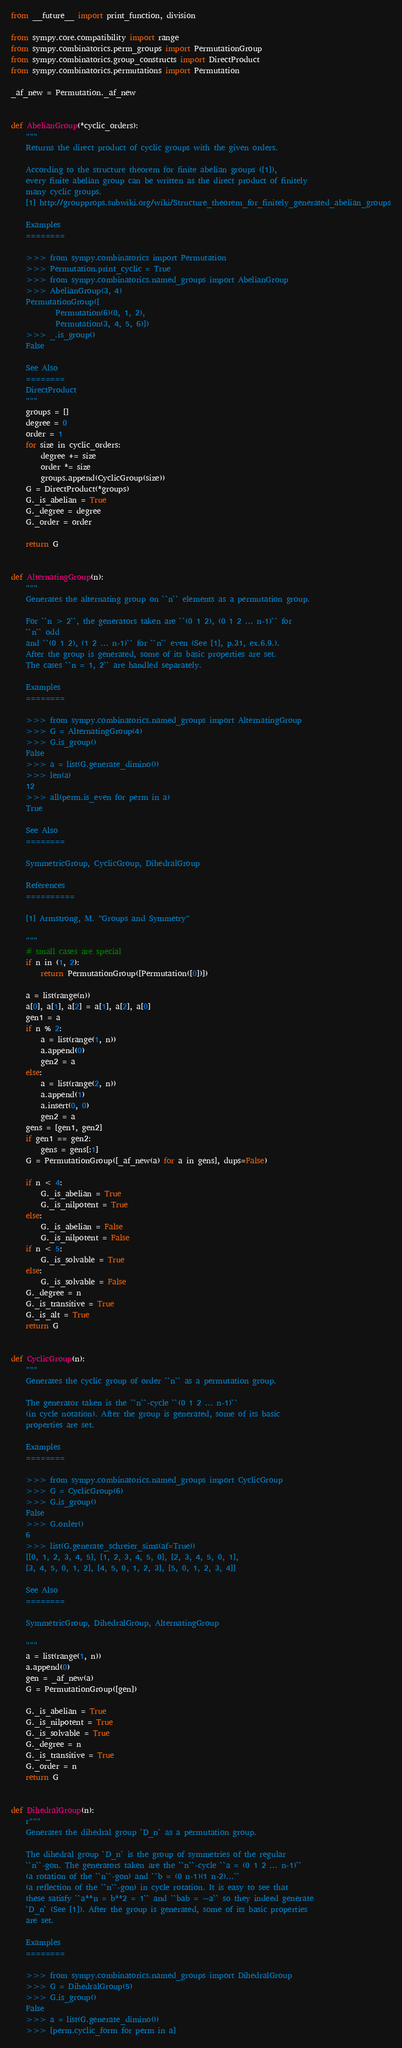Convert code to text. <code><loc_0><loc_0><loc_500><loc_500><_Python_>from __future__ import print_function, division

from sympy.core.compatibility import range
from sympy.combinatorics.perm_groups import PermutationGroup
from sympy.combinatorics.group_constructs import DirectProduct
from sympy.combinatorics.permutations import Permutation

_af_new = Permutation._af_new


def AbelianGroup(*cyclic_orders):
    """
    Returns the direct product of cyclic groups with the given orders.

    According to the structure theorem for finite abelian groups ([1]),
    every finite abelian group can be written as the direct product of finitely
    many cyclic groups.
    [1] http://groupprops.subwiki.org/wiki/Structure_theorem_for_finitely_generated_abelian_groups

    Examples
    ========

    >>> from sympy.combinatorics import Permutation
    >>> Permutation.print_cyclic = True
    >>> from sympy.combinatorics.named_groups import AbelianGroup
    >>> AbelianGroup(3, 4)
    PermutationGroup([
            Permutation(6)(0, 1, 2),
            Permutation(3, 4, 5, 6)])
    >>> _.is_group()
    False

    See Also
    ========
    DirectProduct
    """
    groups = []
    degree = 0
    order = 1
    for size in cyclic_orders:
        degree += size
        order *= size
        groups.append(CyclicGroup(size))
    G = DirectProduct(*groups)
    G._is_abelian = True
    G._degree = degree
    G._order = order

    return G


def AlternatingGroup(n):
    """
    Generates the alternating group on ``n`` elements as a permutation group.

    For ``n > 2``, the generators taken are ``(0 1 2), (0 1 2 ... n-1)`` for
    ``n`` odd
    and ``(0 1 2), (1 2 ... n-1)`` for ``n`` even (See [1], p.31, ex.6.9.).
    After the group is generated, some of its basic properties are set.
    The cases ``n = 1, 2`` are handled separately.

    Examples
    ========

    >>> from sympy.combinatorics.named_groups import AlternatingGroup
    >>> G = AlternatingGroup(4)
    >>> G.is_group()
    False
    >>> a = list(G.generate_dimino())
    >>> len(a)
    12
    >>> all(perm.is_even for perm in a)
    True

    See Also
    ========

    SymmetricGroup, CyclicGroup, DihedralGroup

    References
    ==========

    [1] Armstrong, M. "Groups and Symmetry"

    """
    # small cases are special
    if n in (1, 2):
        return PermutationGroup([Permutation([0])])

    a = list(range(n))
    a[0], a[1], a[2] = a[1], a[2], a[0]
    gen1 = a
    if n % 2:
        a = list(range(1, n))
        a.append(0)
        gen2 = a
    else:
        a = list(range(2, n))
        a.append(1)
        a.insert(0, 0)
        gen2 = a
    gens = [gen1, gen2]
    if gen1 == gen2:
        gens = gens[:1]
    G = PermutationGroup([_af_new(a) for a in gens], dups=False)

    if n < 4:
        G._is_abelian = True
        G._is_nilpotent = True
    else:
        G._is_abelian = False
        G._is_nilpotent = False
    if n < 5:
        G._is_solvable = True
    else:
        G._is_solvable = False
    G._degree = n
    G._is_transitive = True
    G._is_alt = True
    return G


def CyclicGroup(n):
    """
    Generates the cyclic group of order ``n`` as a permutation group.

    The generator taken is the ``n``-cycle ``(0 1 2 ... n-1)``
    (in cycle notation). After the group is generated, some of its basic
    properties are set.

    Examples
    ========

    >>> from sympy.combinatorics.named_groups import CyclicGroup
    >>> G = CyclicGroup(6)
    >>> G.is_group()
    False
    >>> G.order()
    6
    >>> list(G.generate_schreier_sims(af=True))
    [[0, 1, 2, 3, 4, 5], [1, 2, 3, 4, 5, 0], [2, 3, 4, 5, 0, 1],
    [3, 4, 5, 0, 1, 2], [4, 5, 0, 1, 2, 3], [5, 0, 1, 2, 3, 4]]

    See Also
    ========

    SymmetricGroup, DihedralGroup, AlternatingGroup

    """
    a = list(range(1, n))
    a.append(0)
    gen = _af_new(a)
    G = PermutationGroup([gen])

    G._is_abelian = True
    G._is_nilpotent = True
    G._is_solvable = True
    G._degree = n
    G._is_transitive = True
    G._order = n
    return G


def DihedralGroup(n):
    r"""
    Generates the dihedral group `D_n` as a permutation group.

    The dihedral group `D_n` is the group of symmetries of the regular
    ``n``-gon. The generators taken are the ``n``-cycle ``a = (0 1 2 ... n-1)``
    (a rotation of the ``n``-gon) and ``b = (0 n-1)(1 n-2)...``
    (a reflection of the ``n``-gon) in cycle rotation. It is easy to see that
    these satisfy ``a**n = b**2 = 1`` and ``bab = ~a`` so they indeed generate
    `D_n` (See [1]). After the group is generated, some of its basic properties
    are set.

    Examples
    ========

    >>> from sympy.combinatorics.named_groups import DihedralGroup
    >>> G = DihedralGroup(5)
    >>> G.is_group()
    False
    >>> a = list(G.generate_dimino())
    >>> [perm.cyclic_form for perm in a]</code> 